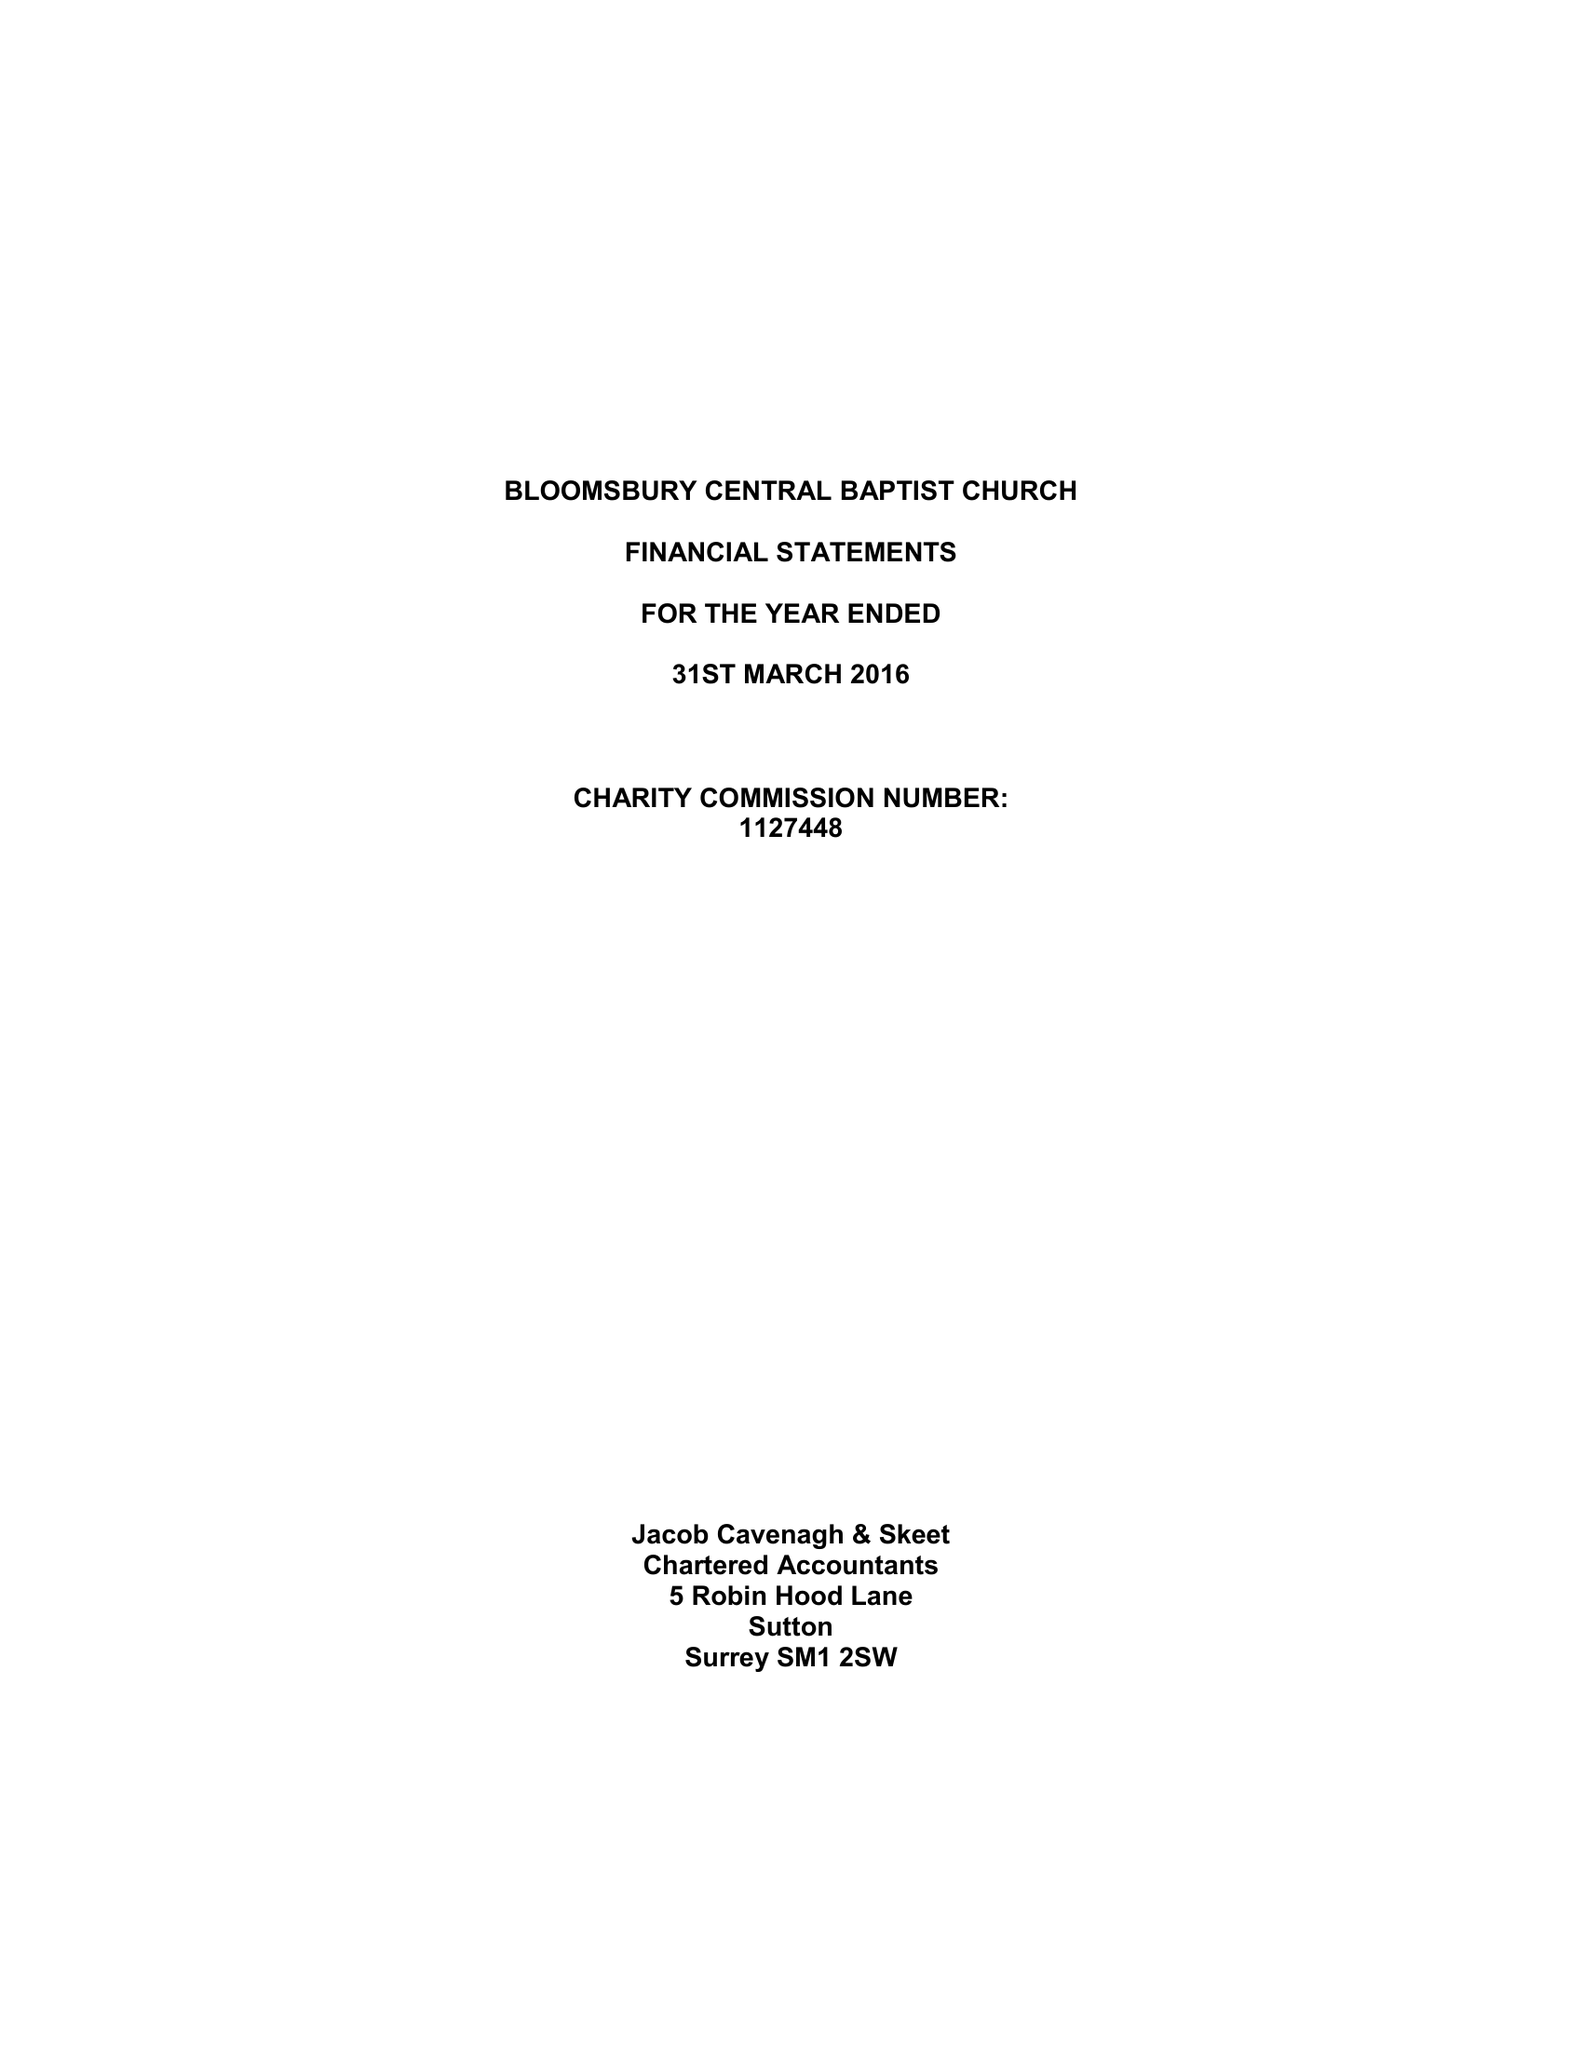What is the value for the address__street_line?
Answer the question using a single word or phrase. 235 SHAFTESBURY AVENUE 